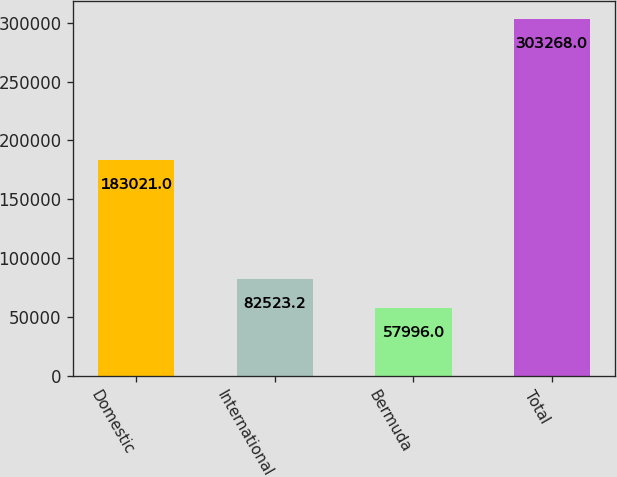Convert chart to OTSL. <chart><loc_0><loc_0><loc_500><loc_500><bar_chart><fcel>Domestic<fcel>International<fcel>Bermuda<fcel>Total<nl><fcel>183021<fcel>82523.2<fcel>57996<fcel>303268<nl></chart> 